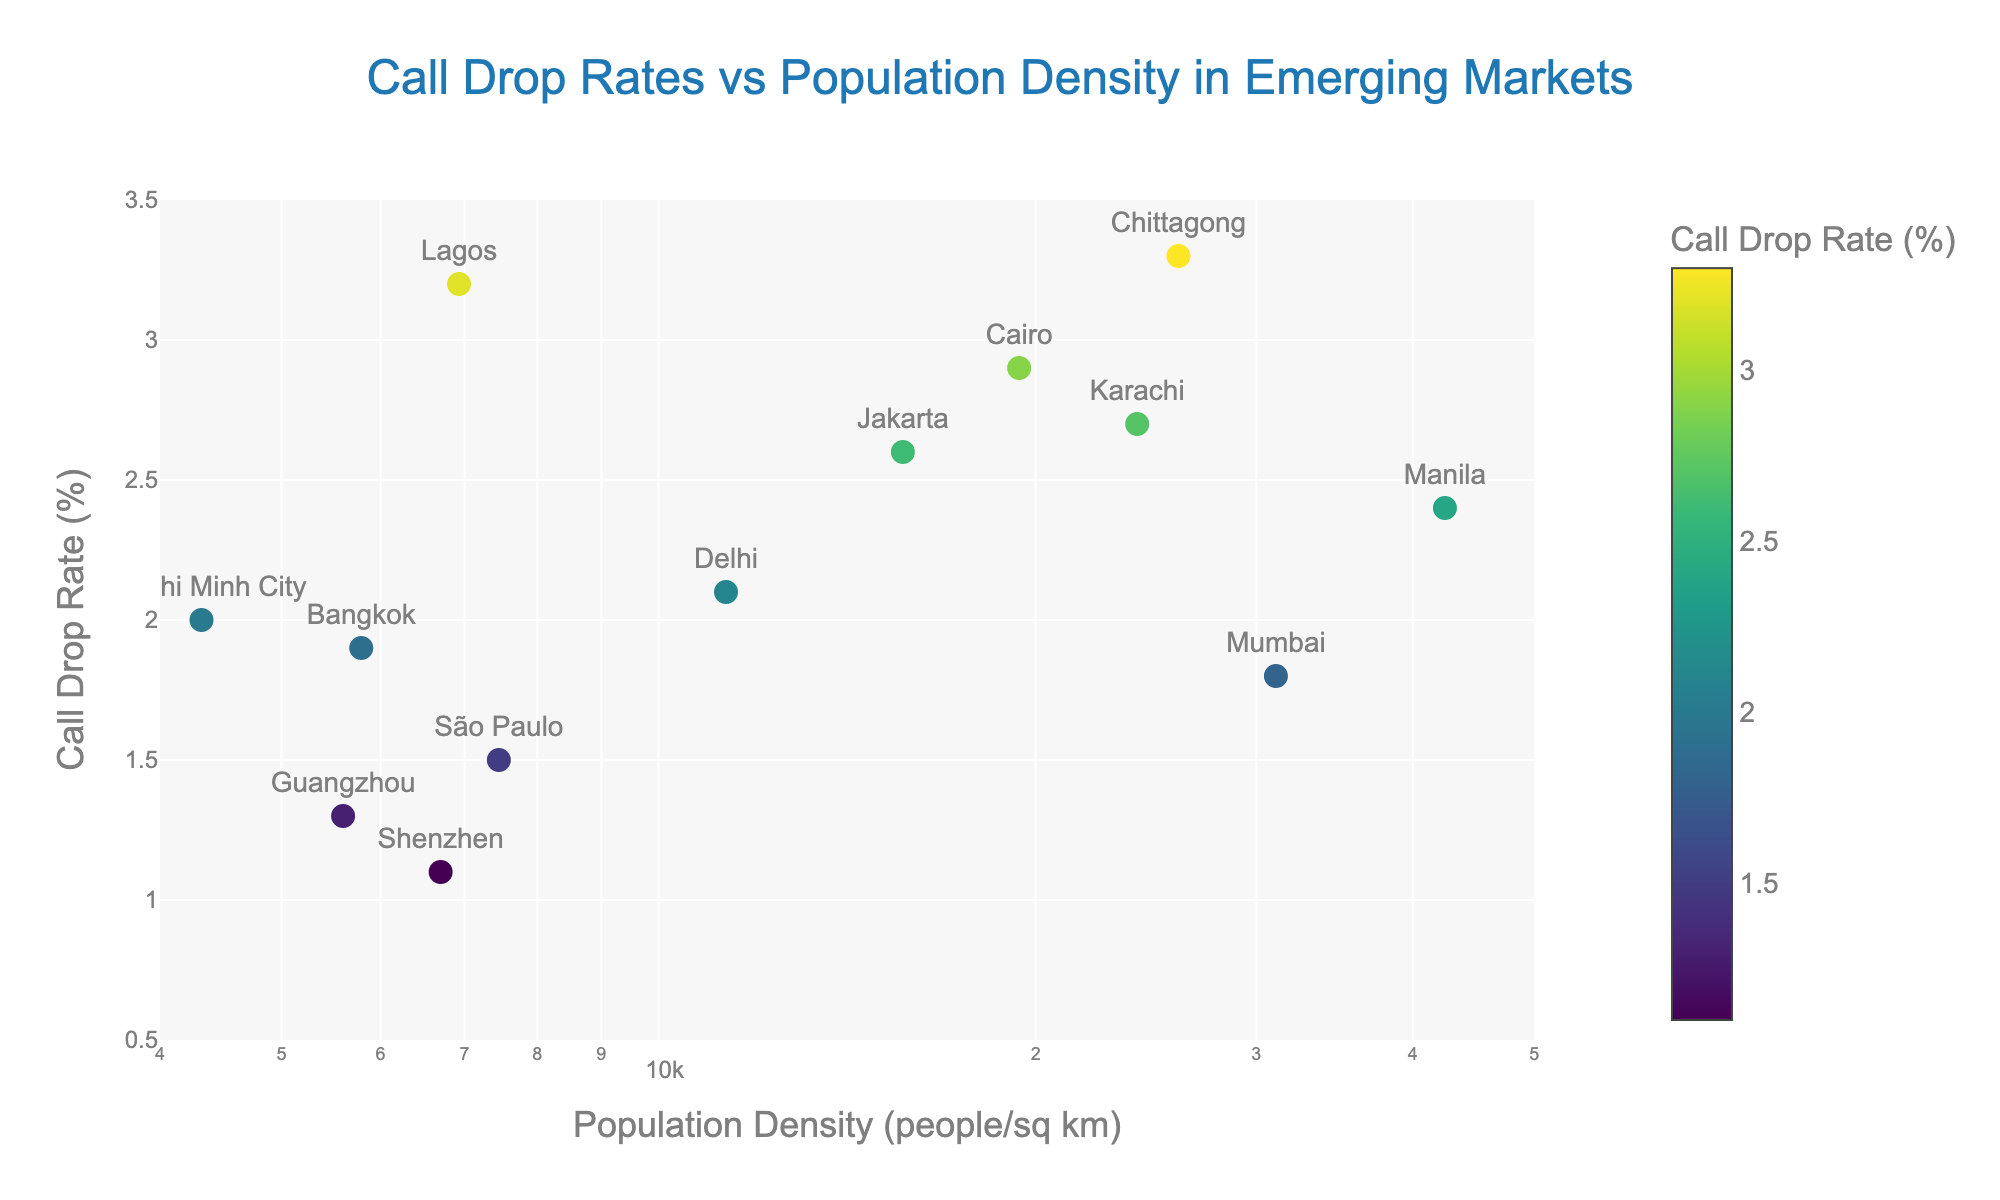What's the title of the plot? The title of the plot is written at the top center part of the figure. It reads “Call Drop Rates vs Population Density in Emerging Markets.”
Answer: Call Drop Rates vs Population Density in Emerging Markets What is the population density range shown on the x-axis? The x-axis is labeled with population density on a logarithmic scale. The visible range on the axis spans from approximately 4000 to 50000 people per square kilometer.
Answer: 4000 to 50000 people/sq km Which city has the highest call drop rate, and what is it? To determine the city with the highest call drop rate, look for the data point with the highest value on the y-axis. The highest call drop rate is 3.3%, corresponding to the city Chittagong.
Answer: Chittagong, 3.3% How does the call drop rate for Manila compare to that of Jakarta? Compare the y-values of the two data points labeled Manila and Jakarta. Manila's call drop rate is 2.4%, while Jakarta's is 2.6%.
Answer: Manila has a lower call drop rate than Jakarta What’s the average call drop rate among the listed cities? Add up the call drop rates and divide by the number of cities. The sum of the rates is 31.8% and the number of cities is 13, so 31.8 / 13 = 2.45%.
Answer: 2.45% Which city has the lowest population density, and what is it? Look for the data point furthest to the left on the x-axis. Ho Chi Minh City has the lowest population density at 4317 people per square kilometer.
Answer: Ho Chi Minh City, 4317 people/sq km Which city appears to have the lowest call drop rate, and what is it? Identify the data point with the lowest value on the y-axis. Shenzhen has the lowest call drop rate at 1.1%.
Answer: Shenzhen, 1.1% Is there a general trend in call drop rates with increasing population density? Observe the scatter plot to see if there is an overall increase or decrease in call drop rates with higher population density. There is no distinct trend showing a clear increase or decrease.
Answer: No distinct trend How many cities have a call drop rate above the overall average? First, calculate the average call drop rate (2.45%). Then, count how many cities have rates above this value. The cities exceeding this are Delhi, Jakarta, Lagos, Chittagong, Cairo, and Karachi, totaling six.
Answer: Six cities Which city has the highest population density, and what is the corresponding call drop rate? Look for the data point furthest to the right on the x-axis. Manila has the highest population density at 42428 people per square kilometer, with a call drop rate of 2.4%.
Answer: Manila, 42428 people/sq km, 2.4% 